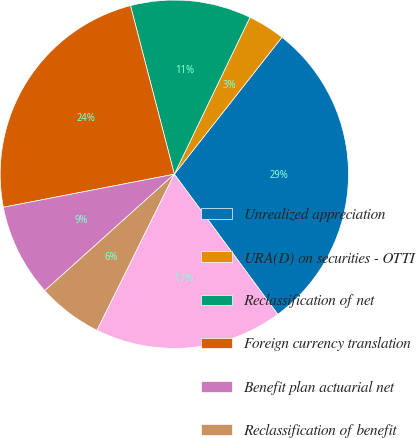Convert chart to OTSL. <chart><loc_0><loc_0><loc_500><loc_500><pie_chart><fcel>Unrealized appreciation<fcel>URA(D) on securities - OTTI<fcel>Reclassification of net<fcel>Foreign currency translation<fcel>Benefit plan actuarial net<fcel>Reclassification of benefit<fcel>Total other comprehensive<nl><fcel>29.28%<fcel>3.45%<fcel>11.2%<fcel>23.99%<fcel>8.61%<fcel>6.03%<fcel>17.44%<nl></chart> 